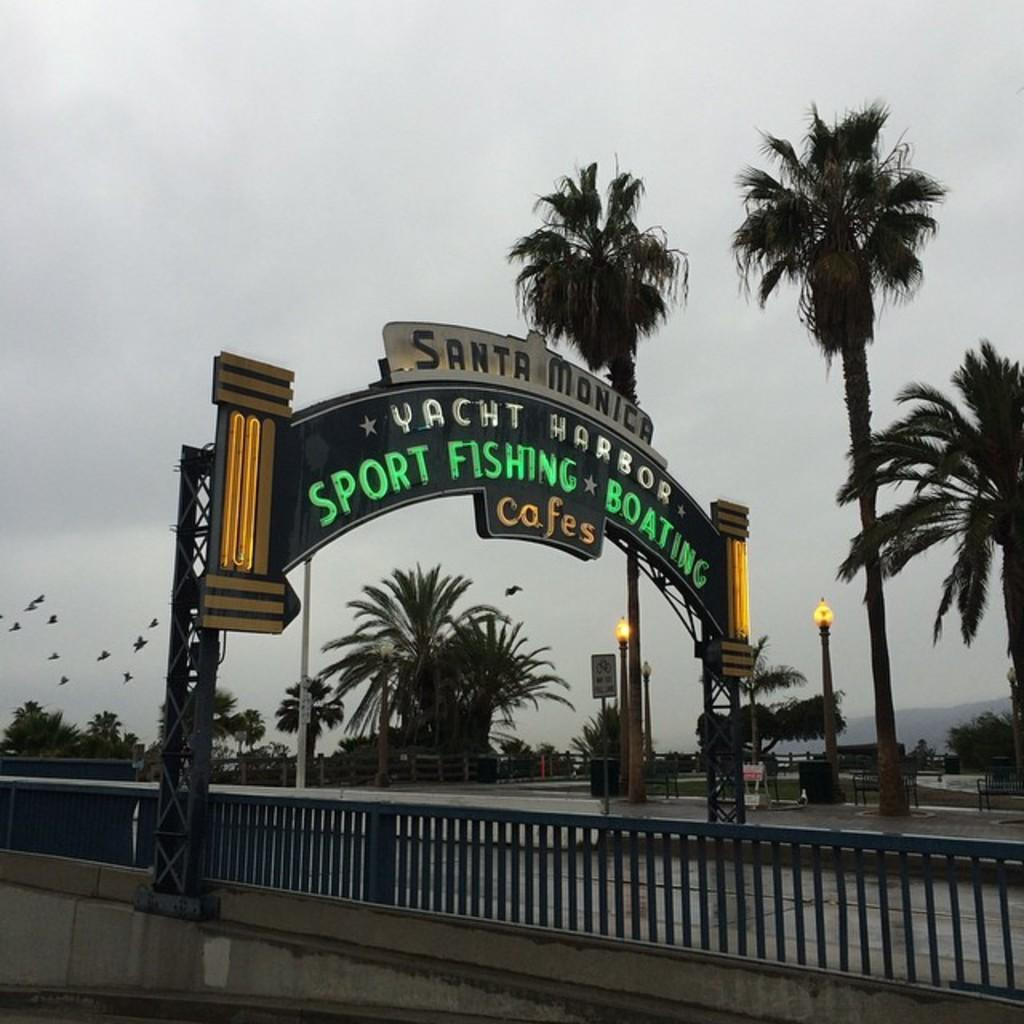What structure can be seen in the image? There is an arch in the image. What is written on the arch? Something is written on the arch. What type of barrier is present in the image? There is a fence in the image. What can be seen in the background of the image? There are trees, the sky, light poles, and a board in the background of the image. What is happening in the sky? Birds are flying in the air, and the sky is cloudy. What type of orange is being used as furniture in the image? There is no orange or furniture present in the image. 